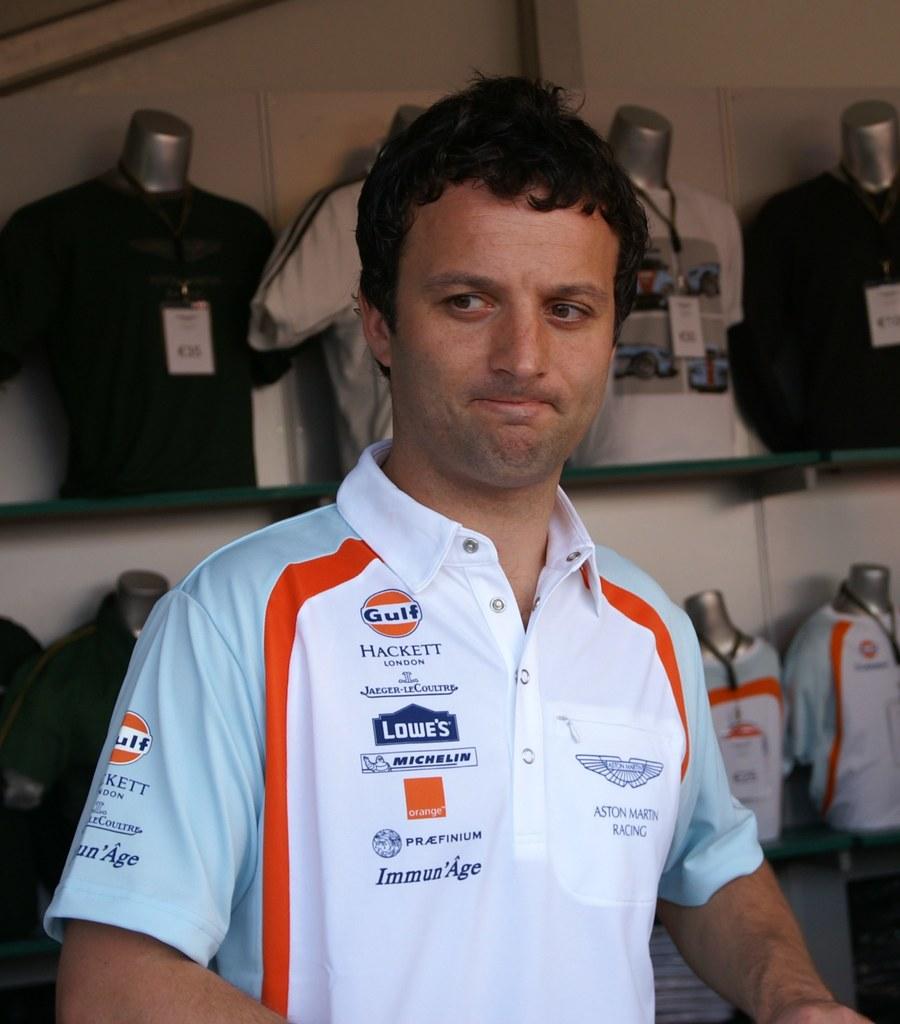What hardware store is a sponsor?
Your answer should be compact. Lowe's. What is the first word printed on the top left of this shirt?
Your answer should be very brief. Gulf. 